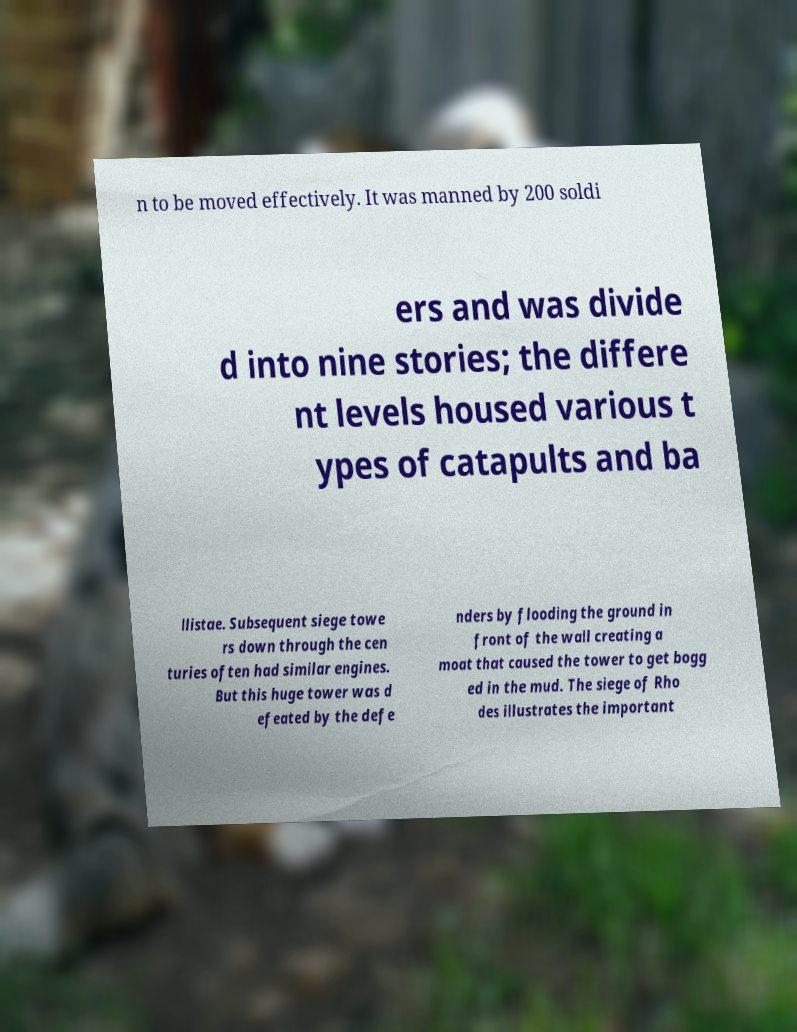Could you extract and type out the text from this image? n to be moved effectively. It was manned by 200 soldi ers and was divide d into nine stories; the differe nt levels housed various t ypes of catapults and ba llistae. Subsequent siege towe rs down through the cen turies often had similar engines. But this huge tower was d efeated by the defe nders by flooding the ground in front of the wall creating a moat that caused the tower to get bogg ed in the mud. The siege of Rho des illustrates the important 